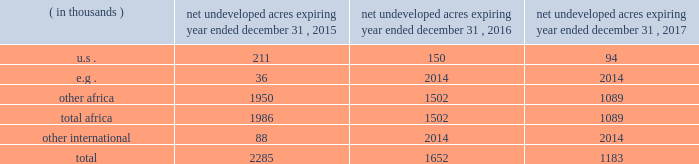In the ordinary course of business , based on our evaluations of certain geologic trends and prospective economics , we have allowed certain lease acreage to expire and may allow additional acreage to expire in the future .
If production is not established or we take no other action to extend the terms of the leases , licenses , or concessions , undeveloped acreage listed in the table below will expire over the next three years .
We plan to continue the terms of many of these licenses and concession areas or retain leases through operational or administrative actions .
Net undeveloped acres expiring year ended december 31 .
Oil sands mining segment we hold a 20 percent non-operated interest in the aosp , an oil sands mining and upgrading joint venture located in alberta , canada .
The joint venture produces bitumen from oil sands deposits in the athabasca region utilizing mining techniques and upgrades the bitumen to synthetic crude oils and vacuum gas oil .
The aosp 2019s mining and extraction assets are located near fort mcmurray , alberta , and include the muskeg river and the jackpine mines .
Gross design capacity of the combined mines is 255000 ( 51000 net to our interest ) barrels of bitumen per day .
The aosp operations use established processes to mine oil sands deposits from an open-pit mine , extract the bitumen and upgrade it into synthetic crude oils .
Ore is mined using traditional truck and shovel mining techniques .
The mined ore passes through primary crushers to reduce the ore chunks in size and is then sent to rotary breakers where the ore chunks are further reduced to smaller particles .
The particles are combined with hot water to create slurry .
The slurry moves through the extraction process where it separates into sand , clay and bitumen-rich froth .
A solvent is added to the bitumen froth to separate out the remaining solids , water and heavy asphaltenes .
The solvent washes the sand and produces clean bitumen that is required for the upgrader to run efficiently .
The process yields a mixture of solvent and bitumen which is then transported from the mine to the scotford upgrader via the approximately 300-mile corridor pipeline .
The aosp's scotford upgrader is located at fort saskatchewan , northeast of edmonton , alberta .
The bitumen is upgraded at scotford using both hydrotreating and hydroconversion processes to remove sulfur and break the heavy bitumen molecules into lighter products .
Blendstocks acquired from outside sources are utilized in the production of our saleable products .
The upgrader produces synthetic crude oils and vacuum gas oil .
The vacuum gas oil is sold to an affiliate of the operator under a long-term contract at market-related prices , and the other products are sold in the marketplace .
As of december 31 , 2014 , we own or have rights to participate in developed and undeveloped leases totaling approximately 163000 gross ( 33000 net ) acres .
The underlying developed leases are held for the duration of the project , with royalties payable to the province of alberta .
Synthetic crude oil sales volumes for 2014 averaged 50 mbbld and net-of-royalty production was 41 mbbld .
In december 2013 , a jackpine mine expansion project received conditional approval from the canadian government .
The project includes additional mining areas , associated processing facilities and infrastructure .
The government conditions relate to wildlife , the environment and aboriginal health issues .
We will evaluate the potential expansion project and government conditions after infrastructure reliability initiatives are completed .
The governments of alberta and canada have agreed to partially fund quest ccs for $ 865 million canadian .
In the third quarter of 2012 , the energy and resources conservation board ( "ercb" ) , alberta's primary energy regulator at that time , conditionally approved the project and the aosp partners approved proceeding to construct and operate quest ccs .
Government funding commenced in 2012 and continued as milestones were achieved during the development , construction and operating phases .
Failure of the aosp to meet certain timing , performance and operating objectives may result in repaying some of the government funding .
Construction and commissioning of quest ccs is expected to be completed by late 2015. .
What percentage of net undeveloped acres are located in the u.s in 2015? 
Computations: (211 / 2285)
Answer: 0.09234. 